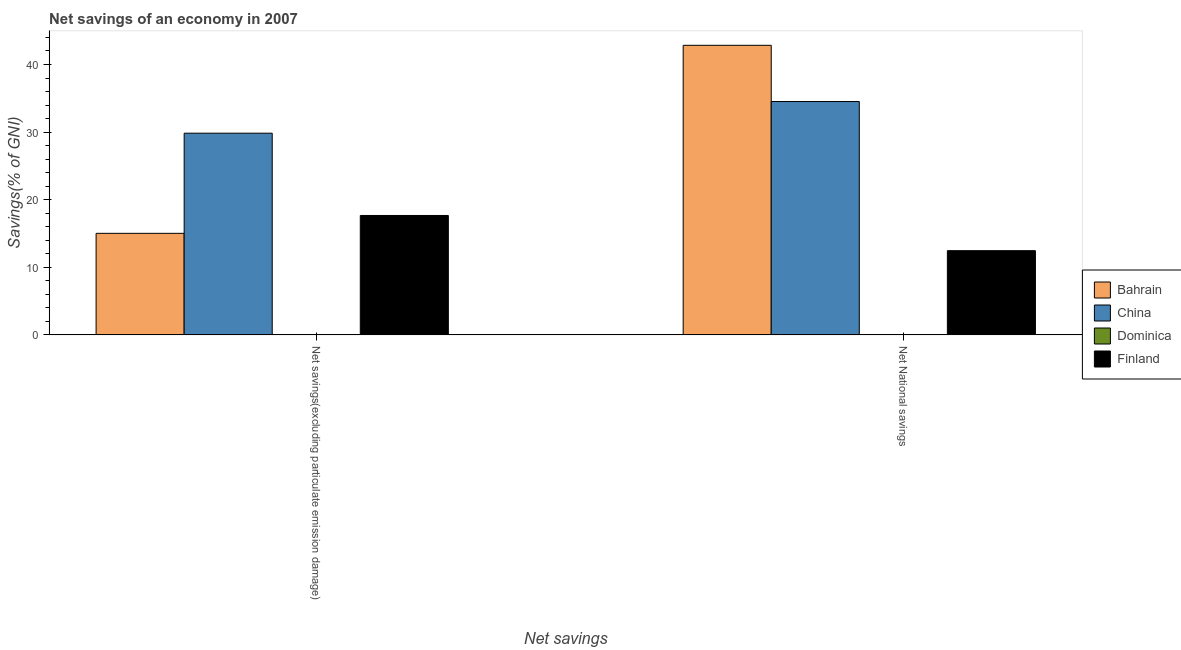How many different coloured bars are there?
Make the answer very short. 3. How many bars are there on the 1st tick from the left?
Keep it short and to the point. 3. What is the label of the 2nd group of bars from the left?
Your answer should be compact. Net National savings. What is the net national savings in Bahrain?
Your answer should be compact. 42.84. Across all countries, what is the maximum net national savings?
Offer a very short reply. 42.84. Across all countries, what is the minimum net savings(excluding particulate emission damage)?
Your answer should be very brief. 0. In which country was the net savings(excluding particulate emission damage) maximum?
Provide a short and direct response. China. What is the total net national savings in the graph?
Offer a very short reply. 89.82. What is the difference between the net national savings in Finland and that in China?
Keep it short and to the point. -22.06. What is the difference between the net savings(excluding particulate emission damage) in Dominica and the net national savings in Bahrain?
Provide a short and direct response. -42.84. What is the average net savings(excluding particulate emission damage) per country?
Make the answer very short. 15.63. What is the difference between the net savings(excluding particulate emission damage) and net national savings in Bahrain?
Provide a short and direct response. -27.82. What is the ratio of the net savings(excluding particulate emission damage) in Finland to that in Bahrain?
Provide a succinct answer. 1.18. In how many countries, is the net national savings greater than the average net national savings taken over all countries?
Ensure brevity in your answer.  2. How many bars are there?
Ensure brevity in your answer.  6. How many countries are there in the graph?
Ensure brevity in your answer.  4. Are the values on the major ticks of Y-axis written in scientific E-notation?
Offer a terse response. No. Does the graph contain grids?
Keep it short and to the point. No. Where does the legend appear in the graph?
Give a very brief answer. Center right. How many legend labels are there?
Offer a very short reply. 4. What is the title of the graph?
Your response must be concise. Net savings of an economy in 2007. What is the label or title of the X-axis?
Make the answer very short. Net savings. What is the label or title of the Y-axis?
Offer a very short reply. Savings(% of GNI). What is the Savings(% of GNI) of Bahrain in Net savings(excluding particulate emission damage)?
Provide a short and direct response. 15.02. What is the Savings(% of GNI) in China in Net savings(excluding particulate emission damage)?
Give a very brief answer. 29.84. What is the Savings(% of GNI) in Finland in Net savings(excluding particulate emission damage)?
Your response must be concise. 17.66. What is the Savings(% of GNI) of Bahrain in Net National savings?
Your response must be concise. 42.84. What is the Savings(% of GNI) in China in Net National savings?
Offer a very short reply. 34.52. What is the Savings(% of GNI) of Dominica in Net National savings?
Provide a succinct answer. 0. What is the Savings(% of GNI) of Finland in Net National savings?
Ensure brevity in your answer.  12.46. Across all Net savings, what is the maximum Savings(% of GNI) of Bahrain?
Ensure brevity in your answer.  42.84. Across all Net savings, what is the maximum Savings(% of GNI) of China?
Your answer should be very brief. 34.52. Across all Net savings, what is the maximum Savings(% of GNI) in Finland?
Your answer should be very brief. 17.66. Across all Net savings, what is the minimum Savings(% of GNI) of Bahrain?
Ensure brevity in your answer.  15.02. Across all Net savings, what is the minimum Savings(% of GNI) in China?
Offer a very short reply. 29.84. Across all Net savings, what is the minimum Savings(% of GNI) in Finland?
Your answer should be very brief. 12.46. What is the total Savings(% of GNI) in Bahrain in the graph?
Your response must be concise. 57.86. What is the total Savings(% of GNI) of China in the graph?
Give a very brief answer. 64.36. What is the total Savings(% of GNI) of Dominica in the graph?
Keep it short and to the point. 0. What is the total Savings(% of GNI) in Finland in the graph?
Provide a short and direct response. 30.12. What is the difference between the Savings(% of GNI) of Bahrain in Net savings(excluding particulate emission damage) and that in Net National savings?
Provide a short and direct response. -27.82. What is the difference between the Savings(% of GNI) in China in Net savings(excluding particulate emission damage) and that in Net National savings?
Your response must be concise. -4.68. What is the difference between the Savings(% of GNI) of Finland in Net savings(excluding particulate emission damage) and that in Net National savings?
Provide a short and direct response. 5.2. What is the difference between the Savings(% of GNI) in Bahrain in Net savings(excluding particulate emission damage) and the Savings(% of GNI) in China in Net National savings?
Your response must be concise. -19.5. What is the difference between the Savings(% of GNI) in Bahrain in Net savings(excluding particulate emission damage) and the Savings(% of GNI) in Finland in Net National savings?
Give a very brief answer. 2.56. What is the difference between the Savings(% of GNI) in China in Net savings(excluding particulate emission damage) and the Savings(% of GNI) in Finland in Net National savings?
Keep it short and to the point. 17.38. What is the average Savings(% of GNI) of Bahrain per Net savings?
Your response must be concise. 28.93. What is the average Savings(% of GNI) of China per Net savings?
Offer a very short reply. 32.18. What is the average Savings(% of GNI) of Dominica per Net savings?
Your response must be concise. 0. What is the average Savings(% of GNI) in Finland per Net savings?
Provide a short and direct response. 15.06. What is the difference between the Savings(% of GNI) in Bahrain and Savings(% of GNI) in China in Net savings(excluding particulate emission damage)?
Your answer should be compact. -14.82. What is the difference between the Savings(% of GNI) of Bahrain and Savings(% of GNI) of Finland in Net savings(excluding particulate emission damage)?
Your answer should be compact. -2.64. What is the difference between the Savings(% of GNI) of China and Savings(% of GNI) of Finland in Net savings(excluding particulate emission damage)?
Keep it short and to the point. 12.17. What is the difference between the Savings(% of GNI) of Bahrain and Savings(% of GNI) of China in Net National savings?
Give a very brief answer. 8.32. What is the difference between the Savings(% of GNI) of Bahrain and Savings(% of GNI) of Finland in Net National savings?
Provide a short and direct response. 30.38. What is the difference between the Savings(% of GNI) of China and Savings(% of GNI) of Finland in Net National savings?
Make the answer very short. 22.06. What is the ratio of the Savings(% of GNI) of Bahrain in Net savings(excluding particulate emission damage) to that in Net National savings?
Keep it short and to the point. 0.35. What is the ratio of the Savings(% of GNI) in China in Net savings(excluding particulate emission damage) to that in Net National savings?
Give a very brief answer. 0.86. What is the ratio of the Savings(% of GNI) in Finland in Net savings(excluding particulate emission damage) to that in Net National savings?
Provide a succinct answer. 1.42. What is the difference between the highest and the second highest Savings(% of GNI) of Bahrain?
Keep it short and to the point. 27.82. What is the difference between the highest and the second highest Savings(% of GNI) of China?
Your answer should be very brief. 4.68. What is the difference between the highest and the second highest Savings(% of GNI) of Finland?
Offer a very short reply. 5.2. What is the difference between the highest and the lowest Savings(% of GNI) in Bahrain?
Keep it short and to the point. 27.82. What is the difference between the highest and the lowest Savings(% of GNI) of China?
Give a very brief answer. 4.68. What is the difference between the highest and the lowest Savings(% of GNI) of Finland?
Offer a very short reply. 5.2. 